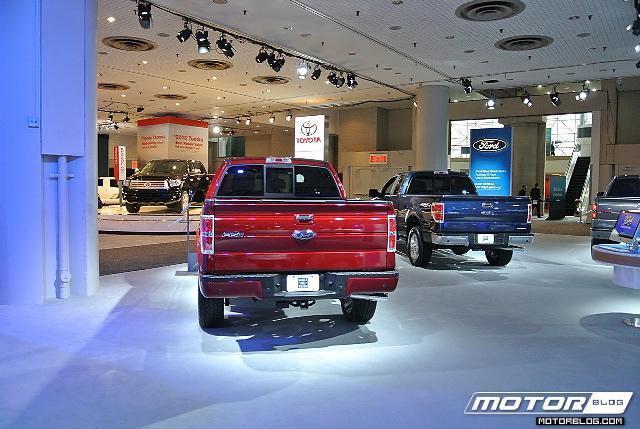How many trucks are visible?
Give a very brief answer. 3. How many horses are in the picture?
Give a very brief answer. 0. 